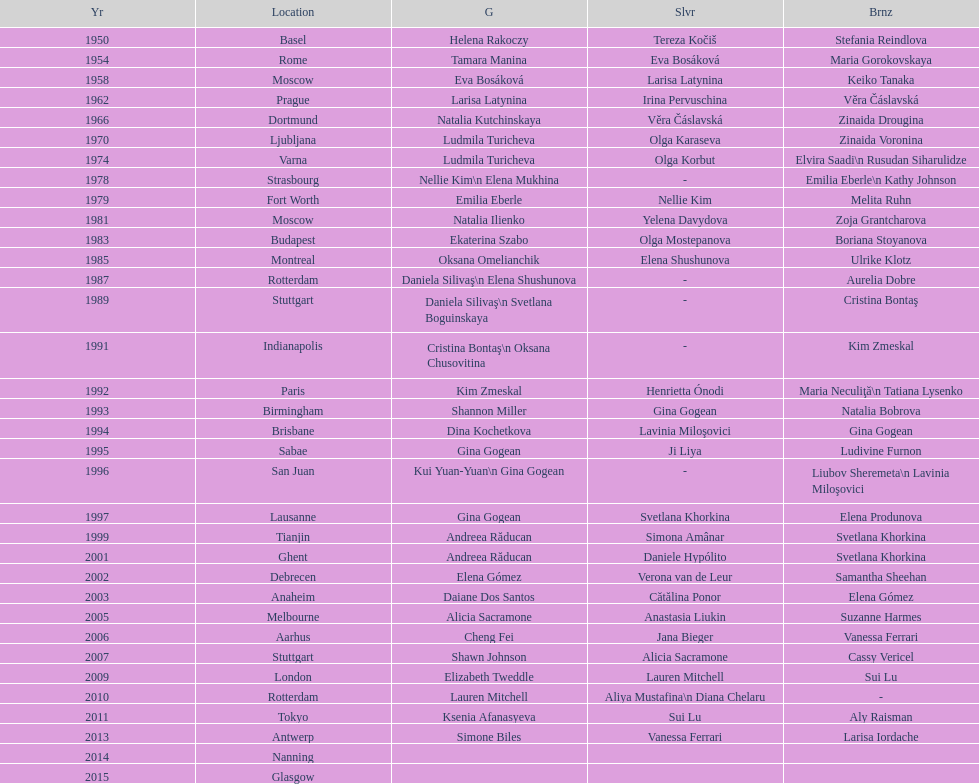Could you parse the entire table as a dict? {'header': ['Yr', 'Location', 'G', 'Slvr', 'Brnz'], 'rows': [['1950', 'Basel', 'Helena Rakoczy', 'Tereza Kočiš', 'Stefania Reindlova'], ['1954', 'Rome', 'Tamara Manina', 'Eva Bosáková', 'Maria Gorokovskaya'], ['1958', 'Moscow', 'Eva Bosáková', 'Larisa Latynina', 'Keiko Tanaka'], ['1962', 'Prague', 'Larisa Latynina', 'Irina Pervuschina', 'Věra Čáslavská'], ['1966', 'Dortmund', 'Natalia Kutchinskaya', 'Věra Čáslavská', 'Zinaida Drougina'], ['1970', 'Ljubljana', 'Ludmila Turicheva', 'Olga Karaseva', 'Zinaida Voronina'], ['1974', 'Varna', 'Ludmila Turicheva', 'Olga Korbut', 'Elvira Saadi\\n Rusudan Siharulidze'], ['1978', 'Strasbourg', 'Nellie Kim\\n Elena Mukhina', '-', 'Emilia Eberle\\n Kathy Johnson'], ['1979', 'Fort Worth', 'Emilia Eberle', 'Nellie Kim', 'Melita Ruhn'], ['1981', 'Moscow', 'Natalia Ilienko', 'Yelena Davydova', 'Zoja Grantcharova'], ['1983', 'Budapest', 'Ekaterina Szabo', 'Olga Mostepanova', 'Boriana Stoyanova'], ['1985', 'Montreal', 'Oksana Omelianchik', 'Elena Shushunova', 'Ulrike Klotz'], ['1987', 'Rotterdam', 'Daniela Silivaş\\n Elena Shushunova', '-', 'Aurelia Dobre'], ['1989', 'Stuttgart', 'Daniela Silivaş\\n Svetlana Boguinskaya', '-', 'Cristina Bontaş'], ['1991', 'Indianapolis', 'Cristina Bontaş\\n Oksana Chusovitina', '-', 'Kim Zmeskal'], ['1992', 'Paris', 'Kim Zmeskal', 'Henrietta Ónodi', 'Maria Neculiţă\\n Tatiana Lysenko'], ['1993', 'Birmingham', 'Shannon Miller', 'Gina Gogean', 'Natalia Bobrova'], ['1994', 'Brisbane', 'Dina Kochetkova', 'Lavinia Miloşovici', 'Gina Gogean'], ['1995', 'Sabae', 'Gina Gogean', 'Ji Liya', 'Ludivine Furnon'], ['1996', 'San Juan', 'Kui Yuan-Yuan\\n Gina Gogean', '-', 'Liubov Sheremeta\\n Lavinia Miloşovici'], ['1997', 'Lausanne', 'Gina Gogean', 'Svetlana Khorkina', 'Elena Produnova'], ['1999', 'Tianjin', 'Andreea Răducan', 'Simona Amânar', 'Svetlana Khorkina'], ['2001', 'Ghent', 'Andreea Răducan', 'Daniele Hypólito', 'Svetlana Khorkina'], ['2002', 'Debrecen', 'Elena Gómez', 'Verona van de Leur', 'Samantha Sheehan'], ['2003', 'Anaheim', 'Daiane Dos Santos', 'Cătălina Ponor', 'Elena Gómez'], ['2005', 'Melbourne', 'Alicia Sacramone', 'Anastasia Liukin', 'Suzanne Harmes'], ['2006', 'Aarhus', 'Cheng Fei', 'Jana Bieger', 'Vanessa Ferrari'], ['2007', 'Stuttgart', 'Shawn Johnson', 'Alicia Sacramone', 'Cassy Vericel'], ['2009', 'London', 'Elizabeth Tweddle', 'Lauren Mitchell', 'Sui Lu'], ['2010', 'Rotterdam', 'Lauren Mitchell', 'Aliya Mustafina\\n Diana Chelaru', '-'], ['2011', 'Tokyo', 'Ksenia Afanasyeva', 'Sui Lu', 'Aly Raisman'], ['2013', 'Antwerp', 'Simone Biles', 'Vanessa Ferrari', 'Larisa Iordache'], ['2014', 'Nanning', '', '', ''], ['2015', 'Glasgow', '', '', '']]} Which two american rivals won consecutive floor exercise gold medals at the artistic gymnastics world championships in 1992 and 1993? Kim Zmeskal, Shannon Miller. 